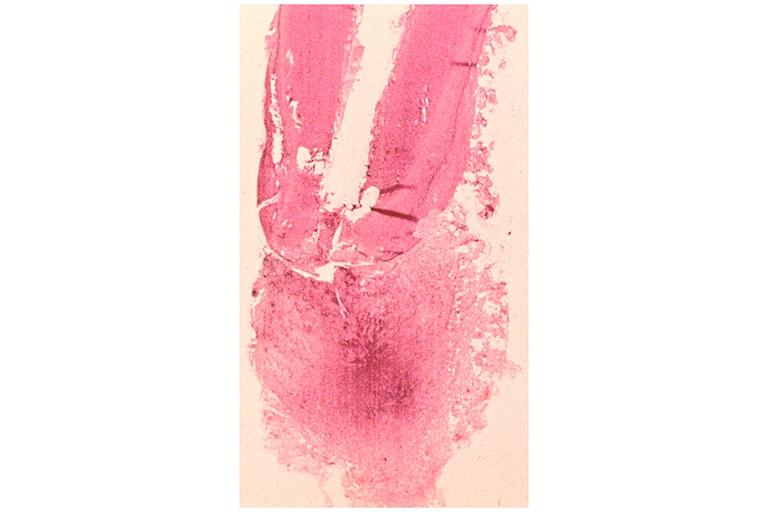what is present?
Answer the question using a single word or phrase. Oral 